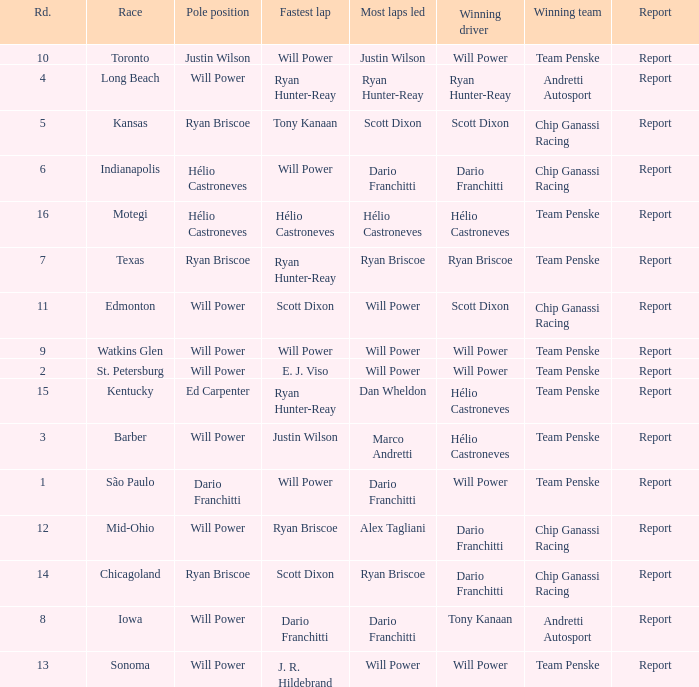What is the report for races where Will Power had both pole position and fastest lap? Report. 